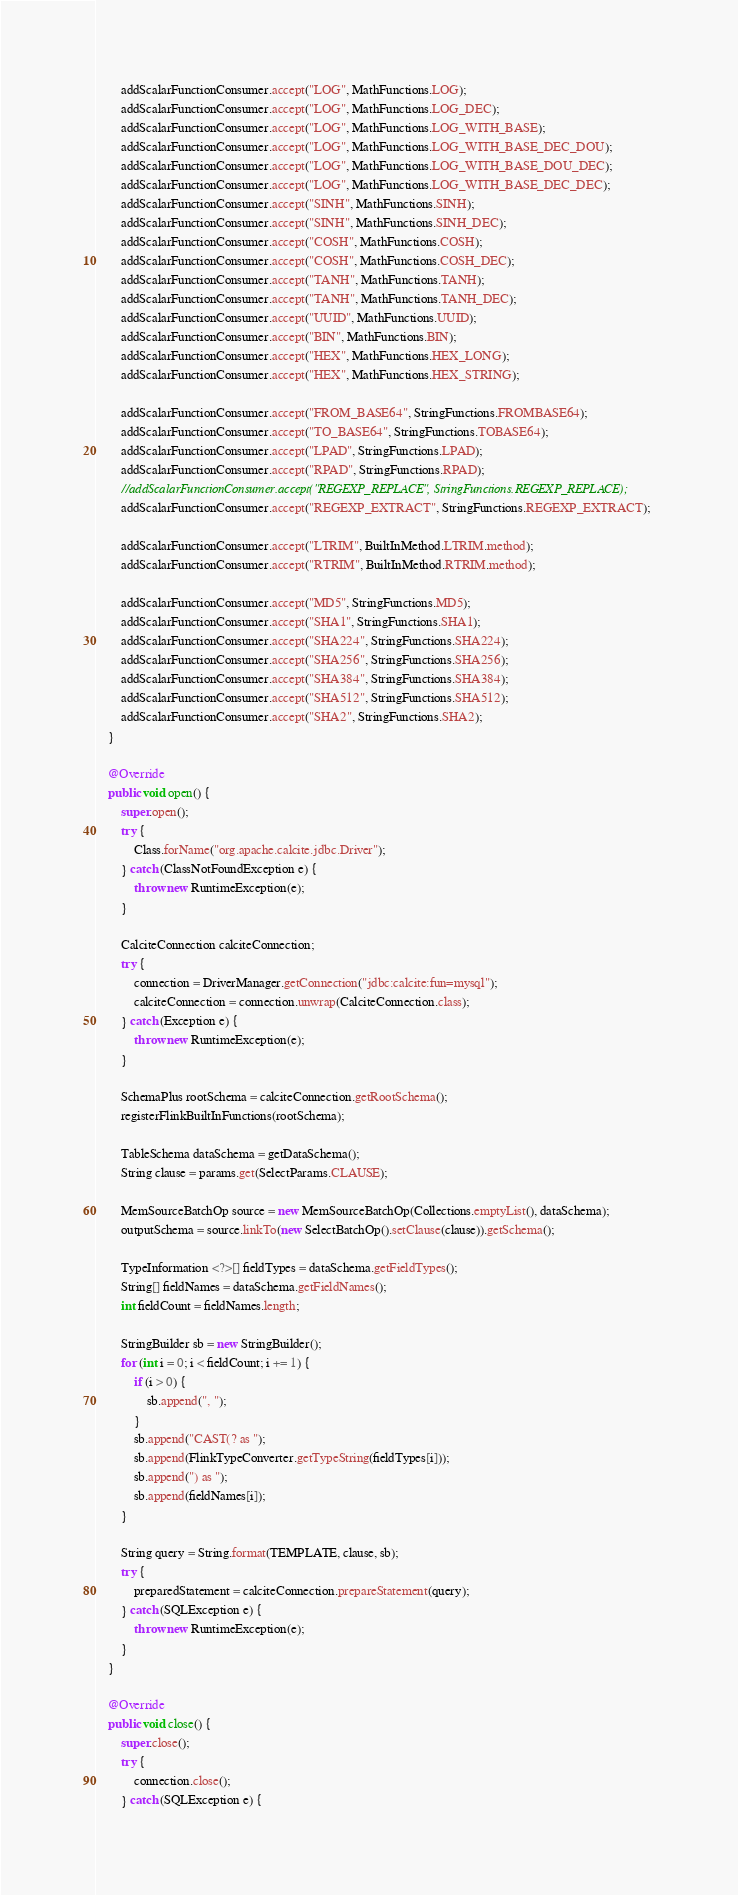Convert code to text. <code><loc_0><loc_0><loc_500><loc_500><_Java_>		addScalarFunctionConsumer.accept("LOG", MathFunctions.LOG);
		addScalarFunctionConsumer.accept("LOG", MathFunctions.LOG_DEC);
		addScalarFunctionConsumer.accept("LOG", MathFunctions.LOG_WITH_BASE);
		addScalarFunctionConsumer.accept("LOG", MathFunctions.LOG_WITH_BASE_DEC_DOU);
		addScalarFunctionConsumer.accept("LOG", MathFunctions.LOG_WITH_BASE_DOU_DEC);
		addScalarFunctionConsumer.accept("LOG", MathFunctions.LOG_WITH_BASE_DEC_DEC);
		addScalarFunctionConsumer.accept("SINH", MathFunctions.SINH);
		addScalarFunctionConsumer.accept("SINH", MathFunctions.SINH_DEC);
		addScalarFunctionConsumer.accept("COSH", MathFunctions.COSH);
		addScalarFunctionConsumer.accept("COSH", MathFunctions.COSH_DEC);
		addScalarFunctionConsumer.accept("TANH", MathFunctions.TANH);
		addScalarFunctionConsumer.accept("TANH", MathFunctions.TANH_DEC);
		addScalarFunctionConsumer.accept("UUID", MathFunctions.UUID);
		addScalarFunctionConsumer.accept("BIN", MathFunctions.BIN);
		addScalarFunctionConsumer.accept("HEX", MathFunctions.HEX_LONG);
		addScalarFunctionConsumer.accept("HEX", MathFunctions.HEX_STRING);

		addScalarFunctionConsumer.accept("FROM_BASE64", StringFunctions.FROMBASE64);
		addScalarFunctionConsumer.accept("TO_BASE64", StringFunctions.TOBASE64);
		addScalarFunctionConsumer.accept("LPAD", StringFunctions.LPAD);
		addScalarFunctionConsumer.accept("RPAD", StringFunctions.RPAD);
		//addScalarFunctionConsumer.accept("REGEXP_REPLACE", StringFunctions.REGEXP_REPLACE);
		addScalarFunctionConsumer.accept("REGEXP_EXTRACT", StringFunctions.REGEXP_EXTRACT);

		addScalarFunctionConsumer.accept("LTRIM", BuiltInMethod.LTRIM.method);
		addScalarFunctionConsumer.accept("RTRIM", BuiltInMethod.RTRIM.method);

		addScalarFunctionConsumer.accept("MD5", StringFunctions.MD5);
		addScalarFunctionConsumer.accept("SHA1", StringFunctions.SHA1);
		addScalarFunctionConsumer.accept("SHA224", StringFunctions.SHA224);
		addScalarFunctionConsumer.accept("SHA256", StringFunctions.SHA256);
		addScalarFunctionConsumer.accept("SHA384", StringFunctions.SHA384);
		addScalarFunctionConsumer.accept("SHA512", StringFunctions.SHA512);
		addScalarFunctionConsumer.accept("SHA2", StringFunctions.SHA2);
	}

	@Override
	public void open() {
		super.open();
		try {
			Class.forName("org.apache.calcite.jdbc.Driver");
		} catch (ClassNotFoundException e) {
			throw new RuntimeException(e);
		}

		CalciteConnection calciteConnection;
		try {
			connection = DriverManager.getConnection("jdbc:calcite:fun=mysql");
			calciteConnection = connection.unwrap(CalciteConnection.class);
		} catch (Exception e) {
			throw new RuntimeException(e);
		}

		SchemaPlus rootSchema = calciteConnection.getRootSchema();
		registerFlinkBuiltInFunctions(rootSchema);

		TableSchema dataSchema = getDataSchema();
		String clause = params.get(SelectParams.CLAUSE);

		MemSourceBatchOp source = new MemSourceBatchOp(Collections.emptyList(), dataSchema);
		outputSchema = source.linkTo(new SelectBatchOp().setClause(clause)).getSchema();

		TypeInformation <?>[] fieldTypes = dataSchema.getFieldTypes();
		String[] fieldNames = dataSchema.getFieldNames();
		int fieldCount = fieldNames.length;

		StringBuilder sb = new StringBuilder();
		for (int i = 0; i < fieldCount; i += 1) {
			if (i > 0) {
				sb.append(", ");
			}
			sb.append("CAST(? as ");
			sb.append(FlinkTypeConverter.getTypeString(fieldTypes[i]));
			sb.append(") as ");
			sb.append(fieldNames[i]);
		}

		String query = String.format(TEMPLATE, clause, sb);
		try {
			preparedStatement = calciteConnection.prepareStatement(query);
		} catch (SQLException e) {
			throw new RuntimeException(e);
		}
	}

	@Override
	public void close() {
		super.close();
		try {
			connection.close();
		} catch (SQLException e) {</code> 